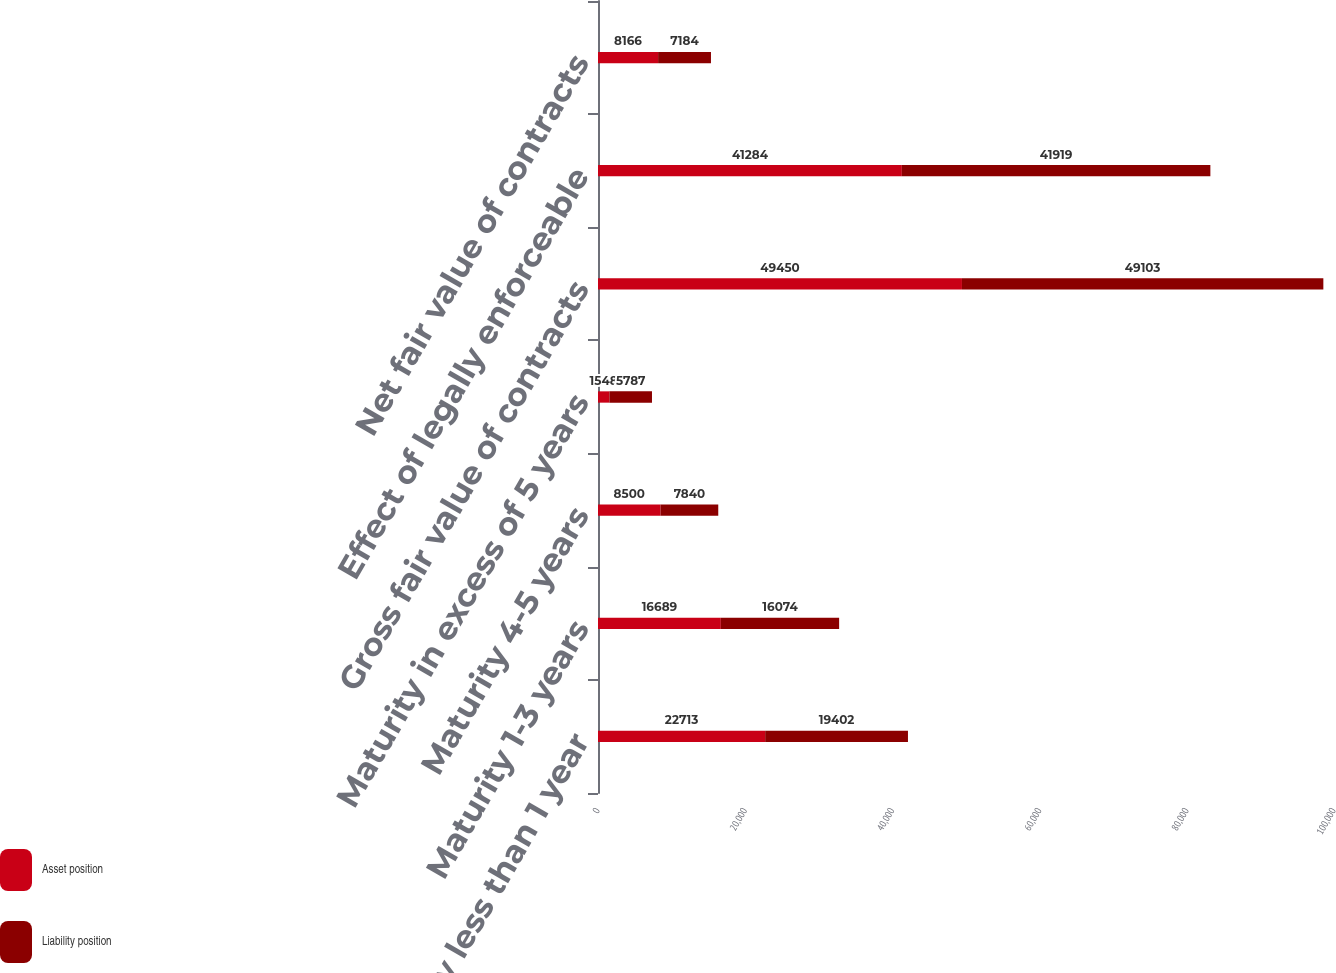Convert chart to OTSL. <chart><loc_0><loc_0><loc_500><loc_500><stacked_bar_chart><ecel><fcel>Maturity less than 1 year<fcel>Maturity 1-3 years<fcel>Maturity 4-5 years<fcel>Maturity in excess of 5 years<fcel>Gross fair value of contracts<fcel>Effect of legally enforceable<fcel>Net fair value of contracts<nl><fcel>Asset position<fcel>22713<fcel>16689<fcel>8500<fcel>1548<fcel>49450<fcel>41284<fcel>8166<nl><fcel>Liability position<fcel>19402<fcel>16074<fcel>7840<fcel>5787<fcel>49103<fcel>41919<fcel>7184<nl></chart> 